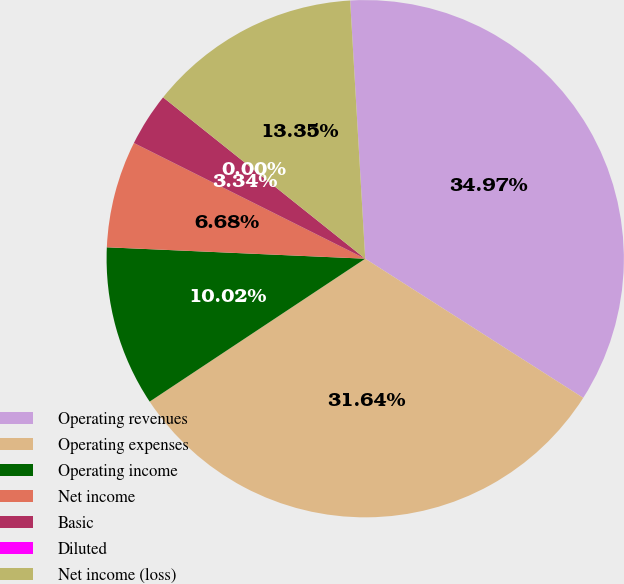<chart> <loc_0><loc_0><loc_500><loc_500><pie_chart><fcel>Operating revenues<fcel>Operating expenses<fcel>Operating income<fcel>Net income<fcel>Basic<fcel>Diluted<fcel>Net income (loss)<nl><fcel>34.97%<fcel>31.64%<fcel>10.02%<fcel>6.68%<fcel>3.34%<fcel>0.0%<fcel>13.35%<nl></chart> 